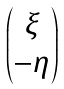<formula> <loc_0><loc_0><loc_500><loc_500>\begin{pmatrix} \xi \\ - \eta \end{pmatrix}</formula> 